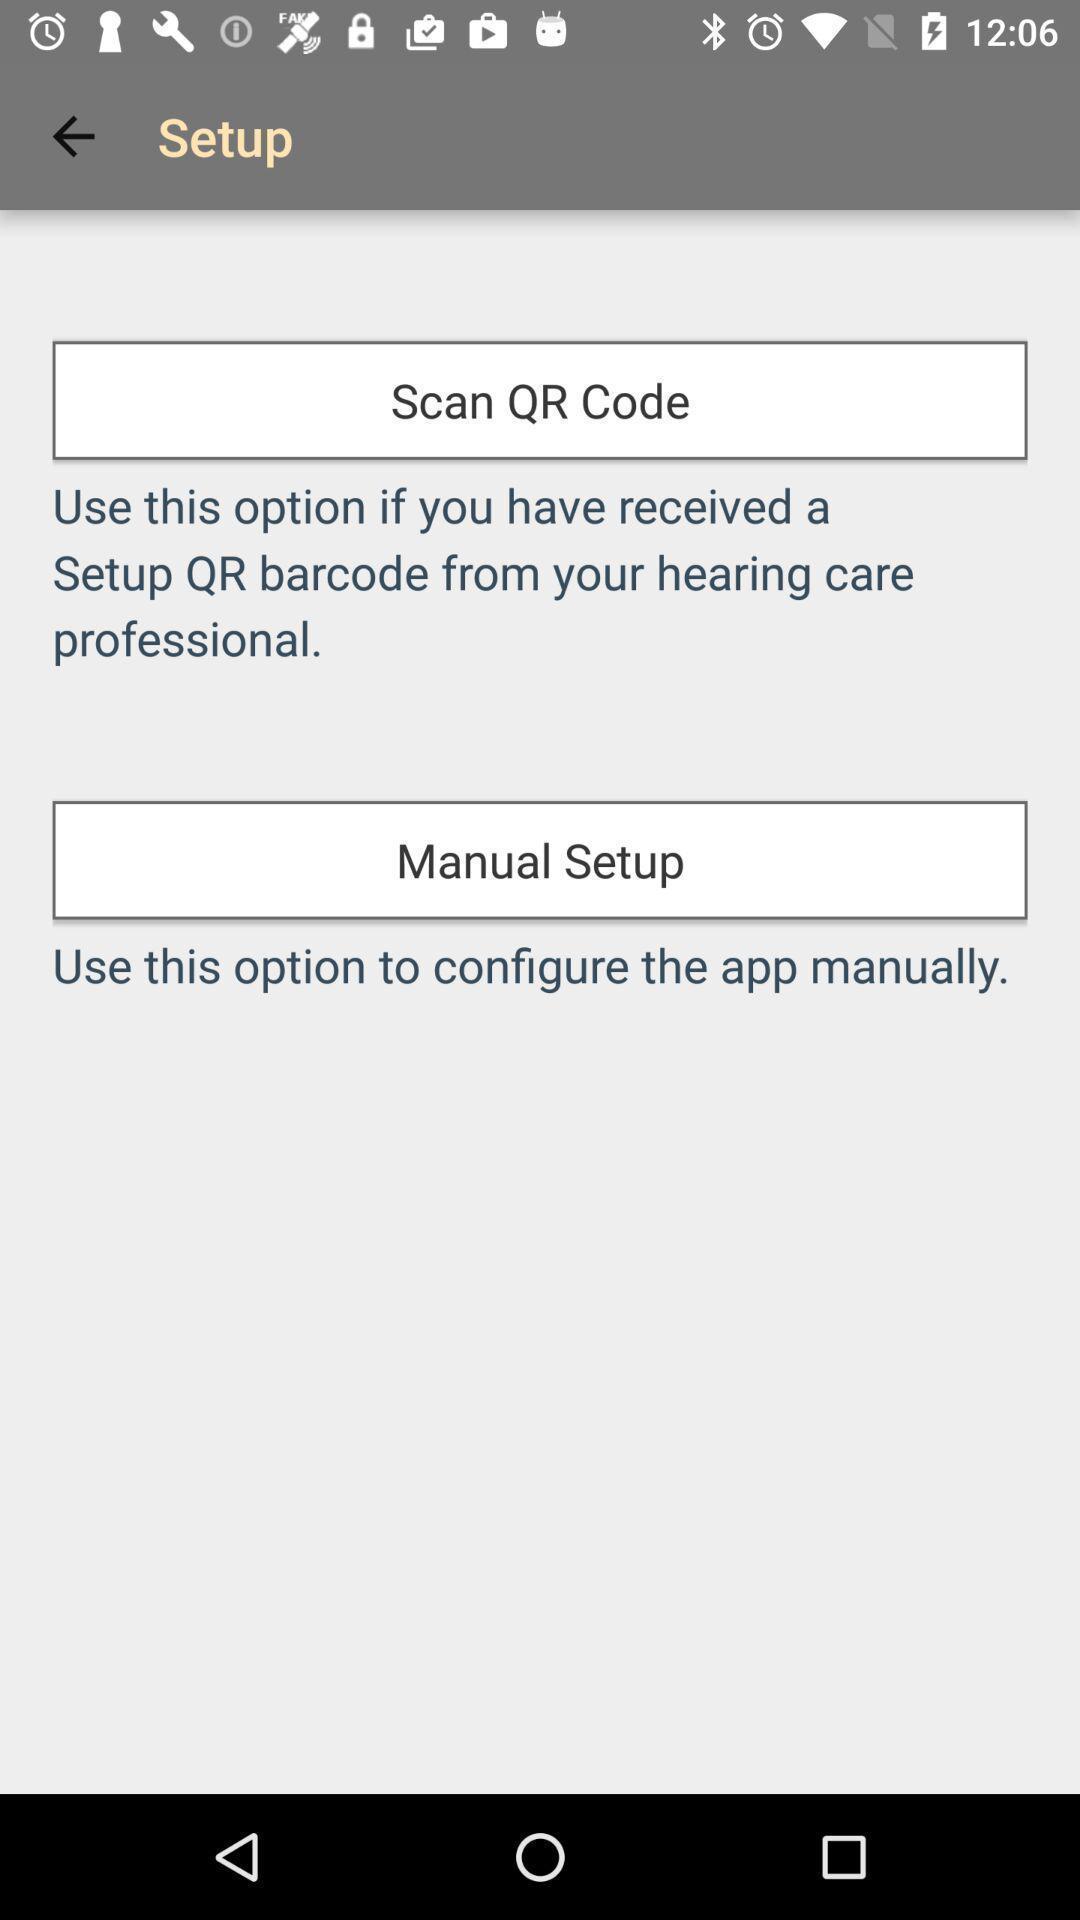What can you discern from this picture? Various types of setup options in the application. 